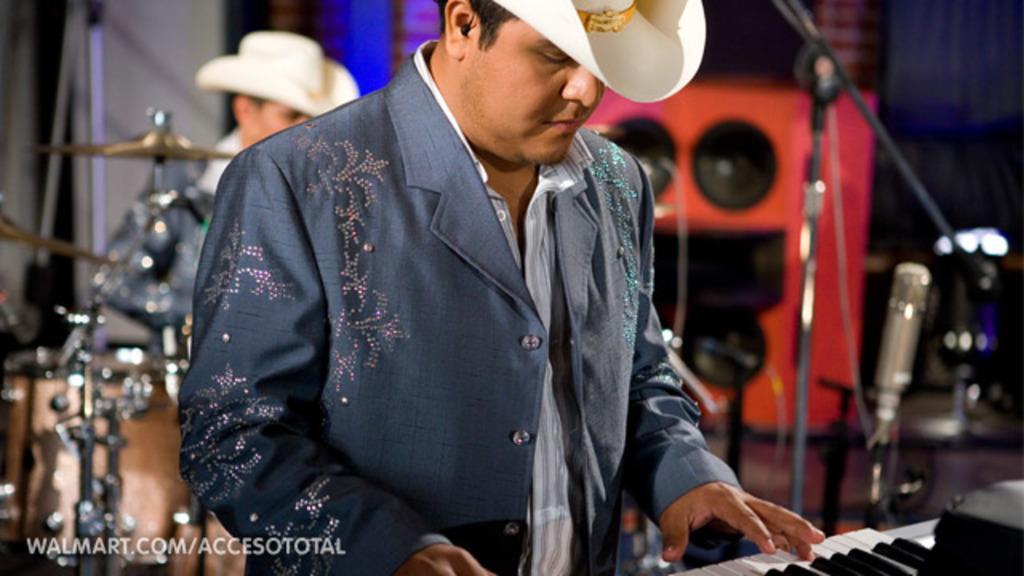Please provide a concise description of this image. In this picture we can see a man playing a piano, the man wore hat and costumes, in the background we can see another person, we can also see some musical instruments like cymbals and drums in the background on the right side of the picture we can see a microphone. 